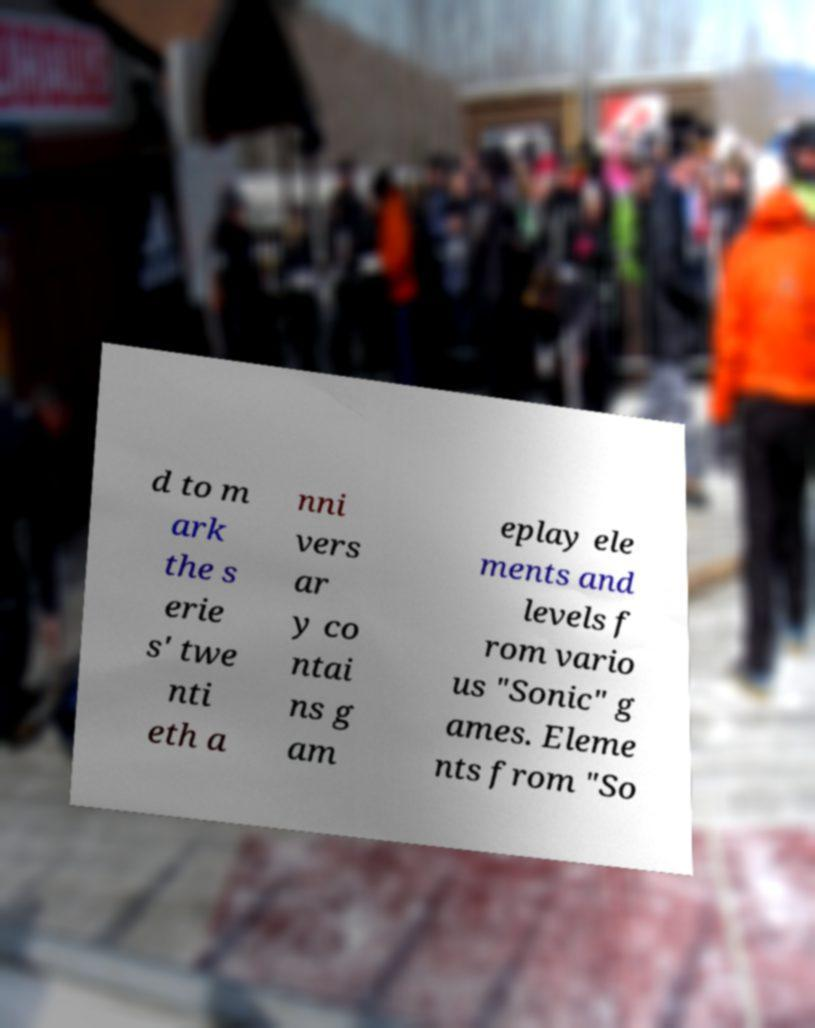Please identify and transcribe the text found in this image. d to m ark the s erie s' twe nti eth a nni vers ar y co ntai ns g am eplay ele ments and levels f rom vario us "Sonic" g ames. Eleme nts from "So 